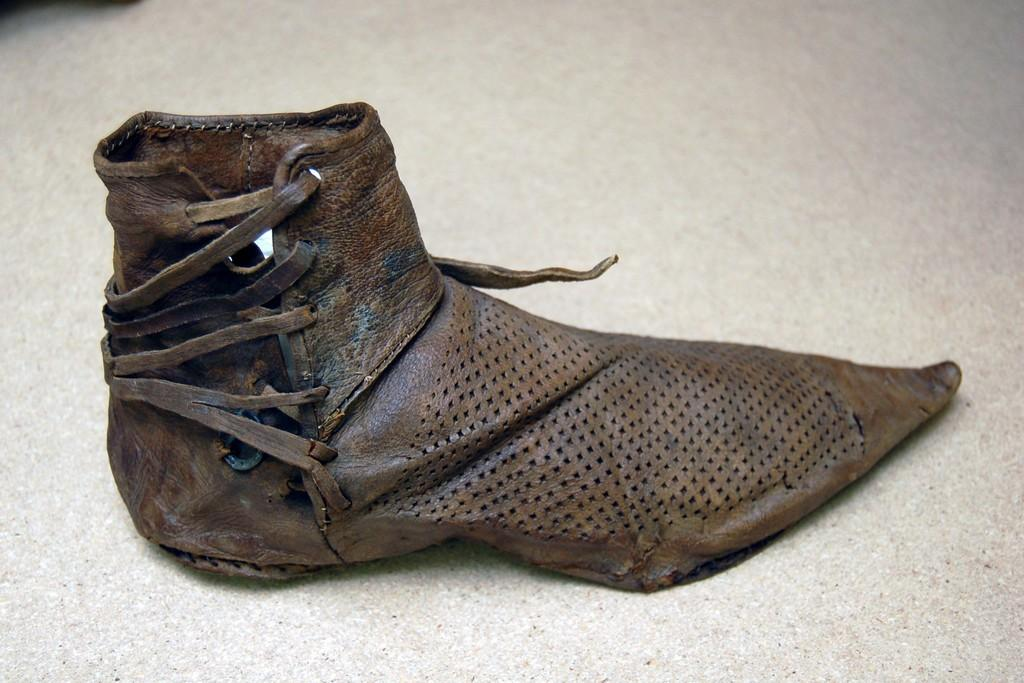What type of shoe is visible in the image? There is a leather shoe in the image. What is the shoe placed on in the image? The leather shoe is placed on a white surface. Where is the kitty sitting in the image? There is no kitty present in the image. 